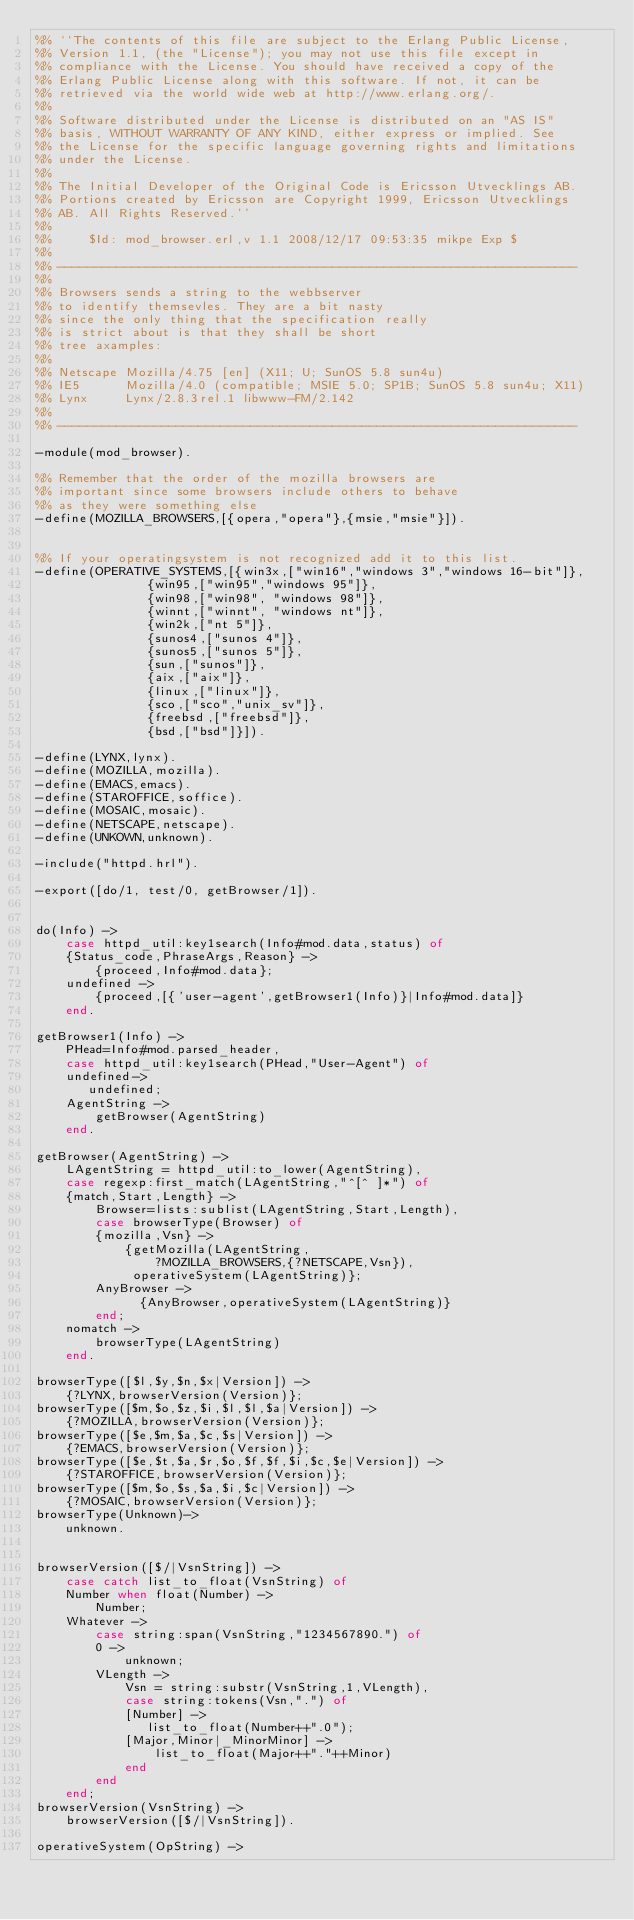Convert code to text. <code><loc_0><loc_0><loc_500><loc_500><_Erlang_>%% ``The contents of this file are subject to the Erlang Public License,
%% Version 1.1, (the "License"); you may not use this file except in
%% compliance with the License. You should have received a copy of the
%% Erlang Public License along with this software. If not, it can be
%% retrieved via the world wide web at http://www.erlang.org/.
%%
%% Software distributed under the License is distributed on an "AS IS"
%% basis, WITHOUT WARRANTY OF ANY KIND, either express or implied. See
%% the License for the specific language governing rights and limitations
%% under the License.
%%
%% The Initial Developer of the Original Code is Ericsson Utvecklings AB.
%% Portions created by Ericsson are Copyright 1999, Ericsson Utvecklings
%% AB. All Rights Reserved.''
%%
%%     $Id: mod_browser.erl,v 1.1 2008/12/17 09:53:35 mikpe Exp $
%%
%% ----------------------------------------------------------------------
%%
%% Browsers sends a string to the webbserver
%% to identify themsevles. They are a bit nasty
%% since the only thing that the specification really
%% is strict about is that they shall be short
%% tree axamples:
%%
%% Netscape Mozilla/4.75 [en] (X11; U; SunOS 5.8 sun4u)
%% IE5      Mozilla/4.0 (compatible; MSIE 5.0; SP1B; SunOS 5.8 sun4u; X11)
%% Lynx     Lynx/2.8.3rel.1 libwww-FM/2.142
%%
%% ----------------------------------------------------------------------

-module(mod_browser).

%% Remember that the order of the mozilla browsers are
%% important since some browsers include others to behave
%% as they were something else
-define(MOZILLA_BROWSERS,[{opera,"opera"},{msie,"msie"}]).


%% If your operatingsystem is not recognized add it to this list.
-define(OPERATIVE_SYSTEMS,[{win3x,["win16","windows 3","windows 16-bit"]},
			   {win95,["win95","windows 95"]},
			   {win98,["win98", "windows 98"]},
			   {winnt,["winnt", "windows nt"]},
			   {win2k,["nt 5"]},
			   {sunos4,["sunos 4"]},
			   {sunos5,["sunos 5"]},
			   {sun,["sunos"]},
			   {aix,["aix"]},
			   {linux,["linux"]},
			   {sco,["sco","unix_sv"]},
			   {freebsd,["freebsd"]},
			   {bsd,["bsd"]}]).

-define(LYNX,lynx).
-define(MOZILLA,mozilla).
-define(EMACS,emacs).
-define(STAROFFICE,soffice).
-define(MOSAIC,mosaic).
-define(NETSCAPE,netscape).
-define(UNKOWN,unknown).

-include("httpd.hrl").

-export([do/1, test/0, getBrowser/1]).


do(Info) ->
    case httpd_util:key1search(Info#mod.data,status) of
	{Status_code,PhraseArgs,Reason} ->
	    {proceed,Info#mod.data};
	undefined ->
	    {proceed,[{'user-agent',getBrowser1(Info)}|Info#mod.data]}
    end.

getBrowser1(Info) ->
    PHead=Info#mod.parsed_header,
    case httpd_util:key1search(PHead,"User-Agent") of
	undefined->
	   undefined;
	AgentString ->
	    getBrowser(AgentString)
    end.

getBrowser(AgentString) ->
    LAgentString = httpd_util:to_lower(AgentString),
    case regexp:first_match(LAgentString,"^[^ ]*") of
	{match,Start,Length} ->
	    Browser=lists:sublist(LAgentString,Start,Length),
	    case browserType(Browser) of
		{mozilla,Vsn} ->
		    {getMozilla(LAgentString,
				?MOZILLA_BROWSERS,{?NETSCAPE,Vsn}),
		     operativeSystem(LAgentString)};
		AnyBrowser ->
		      {AnyBrowser,operativeSystem(LAgentString)}
	    end;
	nomatch ->
	    browserType(LAgentString)
    end.

browserType([$l,$y,$n,$x|Version]) ->
    {?LYNX,browserVersion(Version)};
browserType([$m,$o,$z,$i,$l,$l,$a|Version]) ->
    {?MOZILLA,browserVersion(Version)};
browserType([$e,$m,$a,$c,$s|Version]) ->
    {?EMACS,browserVersion(Version)};
browserType([$e,$t,$a,$r,$o,$f,$f,$i,$c,$e|Version]) ->
    {?STAROFFICE,browserVersion(Version)};
browserType([$m,$o,$s,$a,$i,$c|Version]) ->
    {?MOSAIC,browserVersion(Version)};
browserType(Unknown)->
    unknown.


browserVersion([$/|VsnString]) ->
    case catch list_to_float(VsnString) of
	Number when float(Number) ->
	    Number;
	Whatever ->
	    case string:span(VsnString,"1234567890.") of
		0 ->
		    unknown;
		VLength ->
		    Vsn = string:substr(VsnString,1,VLength),
		    case string:tokens(Vsn,".") of
			[Number] ->
			   list_to_float(Number++".0");
			[Major,Minor|_MinorMinor] ->
			    list_to_float(Major++"."++Minor)
		    end
	    end
    end;
browserVersion(VsnString) ->
    browserVersion([$/|VsnString]).

operativeSystem(OpString) -></code> 